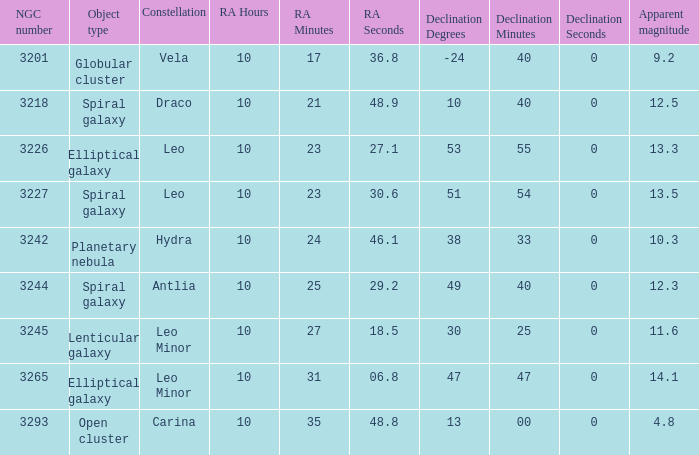What is the total of Apparent magnitudes for an NGC number larger than 3293? None. 